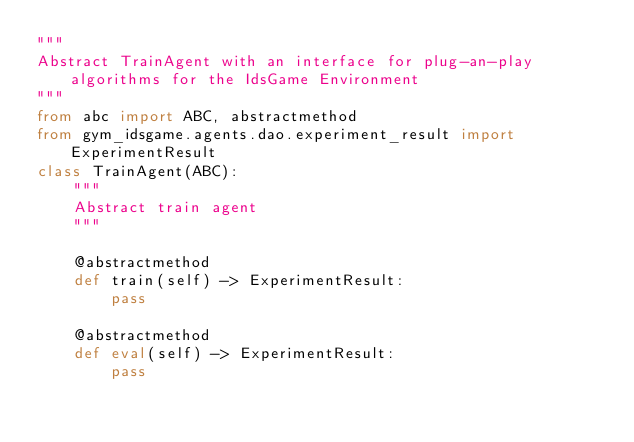Convert code to text. <code><loc_0><loc_0><loc_500><loc_500><_Python_>"""
Abstract TrainAgent with an interface for plug-an-play algorithms for the IdsGame Environment
"""
from abc import ABC, abstractmethod
from gym_idsgame.agents.dao.experiment_result import ExperimentResult
class TrainAgent(ABC):
    """
    Abstract train agent
    """

    @abstractmethod
    def train(self) -> ExperimentResult:
        pass

    @abstractmethod
    def eval(self) -> ExperimentResult:
        pass

</code> 